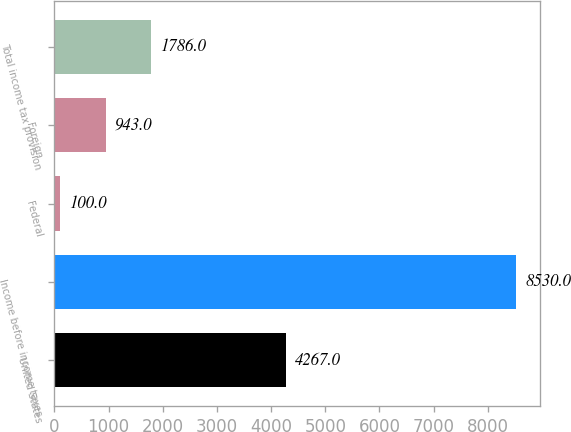Convert chart to OTSL. <chart><loc_0><loc_0><loc_500><loc_500><bar_chart><fcel>United States<fcel>Income before income taxes<fcel>Federal<fcel>Foreign<fcel>Total income tax provision<nl><fcel>4267<fcel>8530<fcel>100<fcel>943<fcel>1786<nl></chart> 